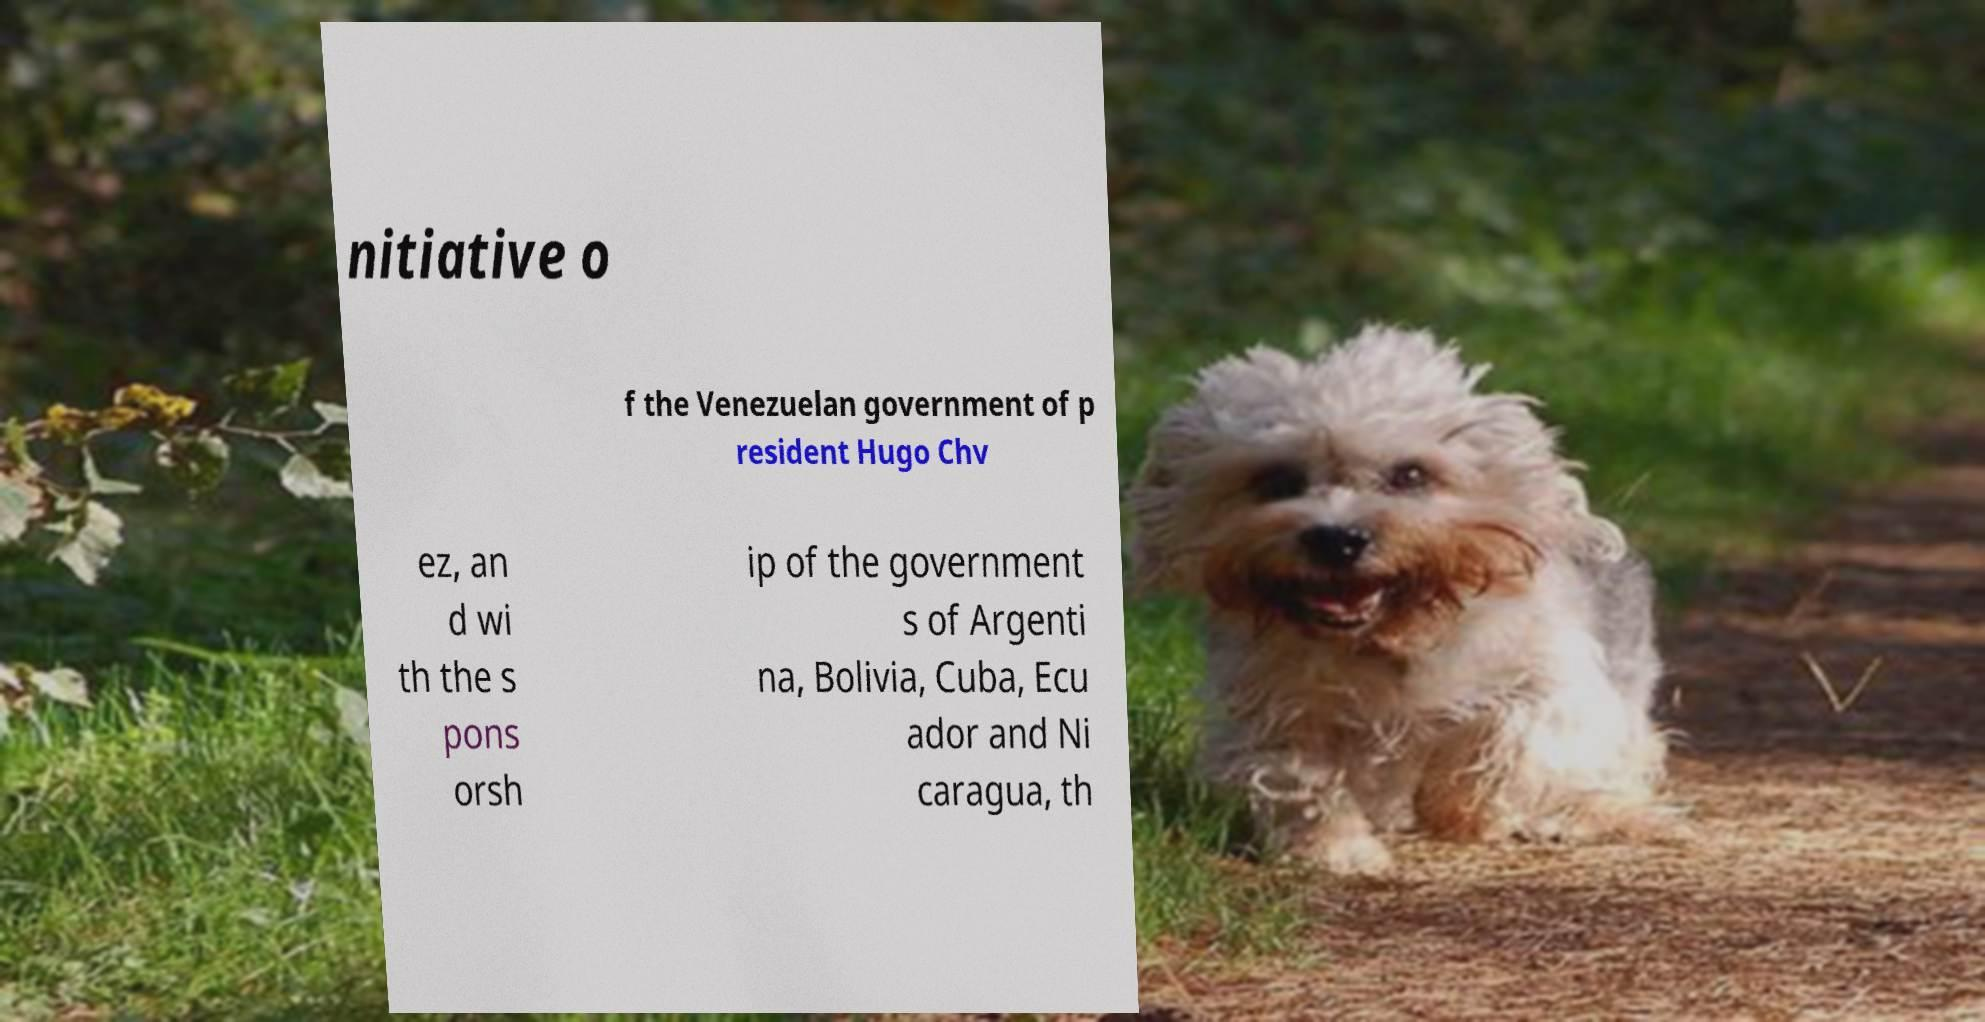Can you read and provide the text displayed in the image?This photo seems to have some interesting text. Can you extract and type it out for me? nitiative o f the Venezuelan government of p resident Hugo Chv ez, an d wi th the s pons orsh ip of the government s of Argenti na, Bolivia, Cuba, Ecu ador and Ni caragua, th 